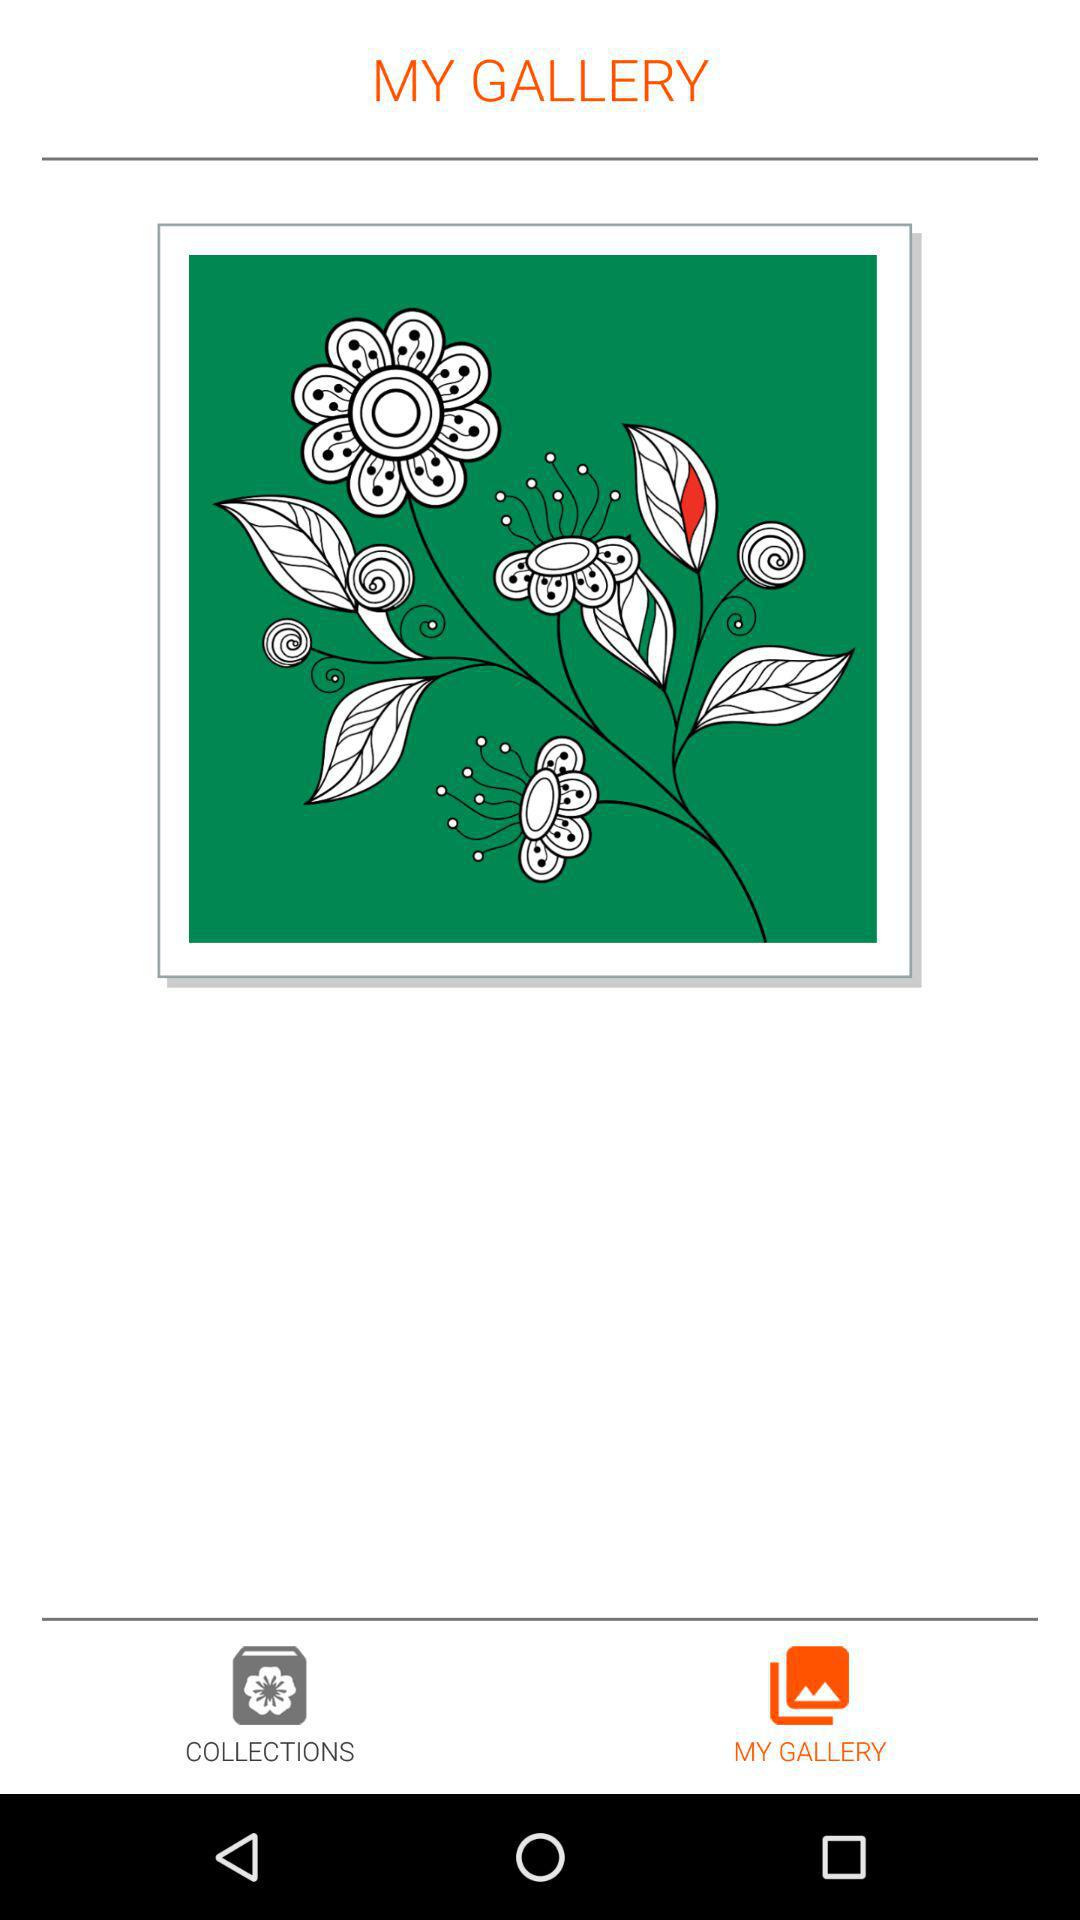Which tab has been selected? The selected tab is "MY GALLERY". 